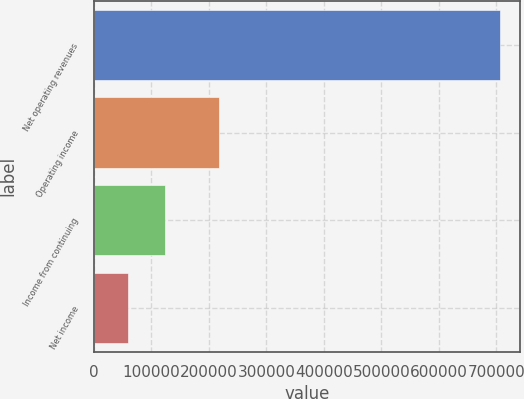Convert chart. <chart><loc_0><loc_0><loc_500><loc_500><bar_chart><fcel>Net operating revenues<fcel>Operating income<fcel>Income from continuing<fcel>Net income<nl><fcel>706242<fcel>217795<fcel>124348<fcel>59693<nl></chart> 